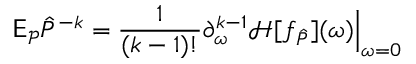Convert formula to latex. <formula><loc_0><loc_0><loc_500><loc_500>\mathsf E _ { \mathcal { P } } \hat { P } ^ { - k } = \frac { 1 } { ( k - 1 ) ! } \partial _ { \omega } ^ { k - 1 } \mathcal { H } [ f _ { \hat { P } } ] ( \omega ) \Big | _ { \omega = 0 }</formula> 